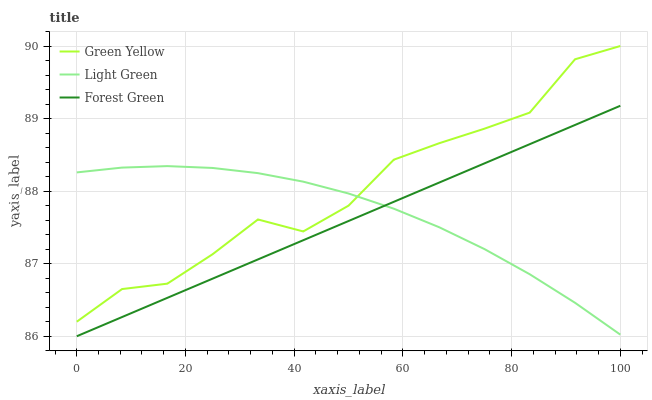Does Forest Green have the minimum area under the curve?
Answer yes or no. Yes. Does Green Yellow have the maximum area under the curve?
Answer yes or no. Yes. Does Light Green have the minimum area under the curve?
Answer yes or no. No. Does Light Green have the maximum area under the curve?
Answer yes or no. No. Is Forest Green the smoothest?
Answer yes or no. Yes. Is Green Yellow the roughest?
Answer yes or no. Yes. Is Light Green the smoothest?
Answer yes or no. No. Is Light Green the roughest?
Answer yes or no. No. Does Forest Green have the lowest value?
Answer yes or no. Yes. Does Light Green have the lowest value?
Answer yes or no. No. Does Green Yellow have the highest value?
Answer yes or no. Yes. Does Light Green have the highest value?
Answer yes or no. No. Is Forest Green less than Green Yellow?
Answer yes or no. Yes. Is Green Yellow greater than Forest Green?
Answer yes or no. Yes. Does Forest Green intersect Light Green?
Answer yes or no. Yes. Is Forest Green less than Light Green?
Answer yes or no. No. Is Forest Green greater than Light Green?
Answer yes or no. No. Does Forest Green intersect Green Yellow?
Answer yes or no. No. 